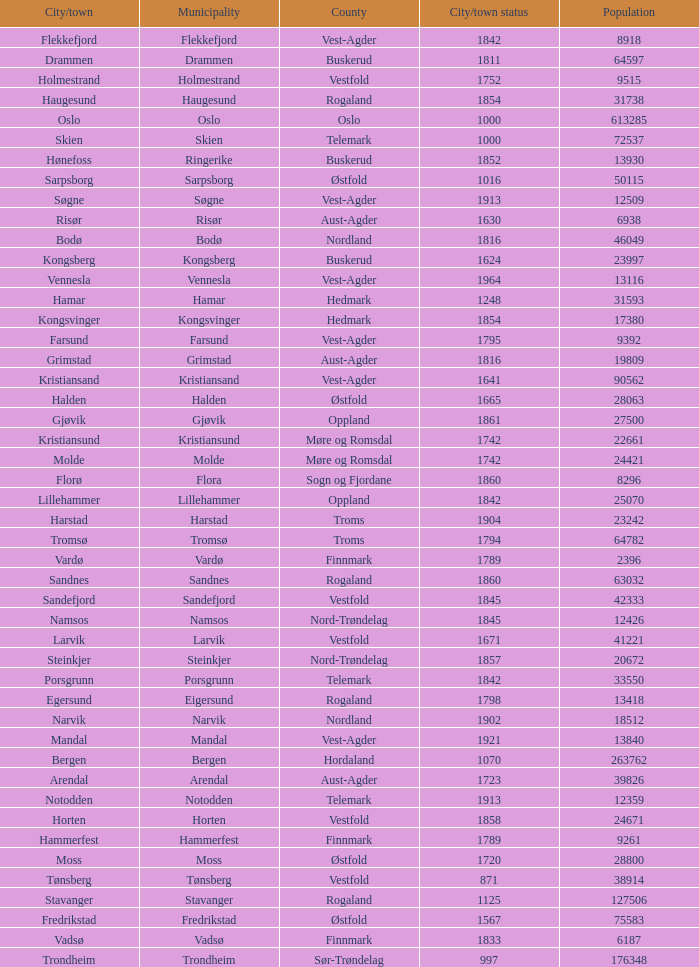Which municipality has a population of 24421? Molde. 